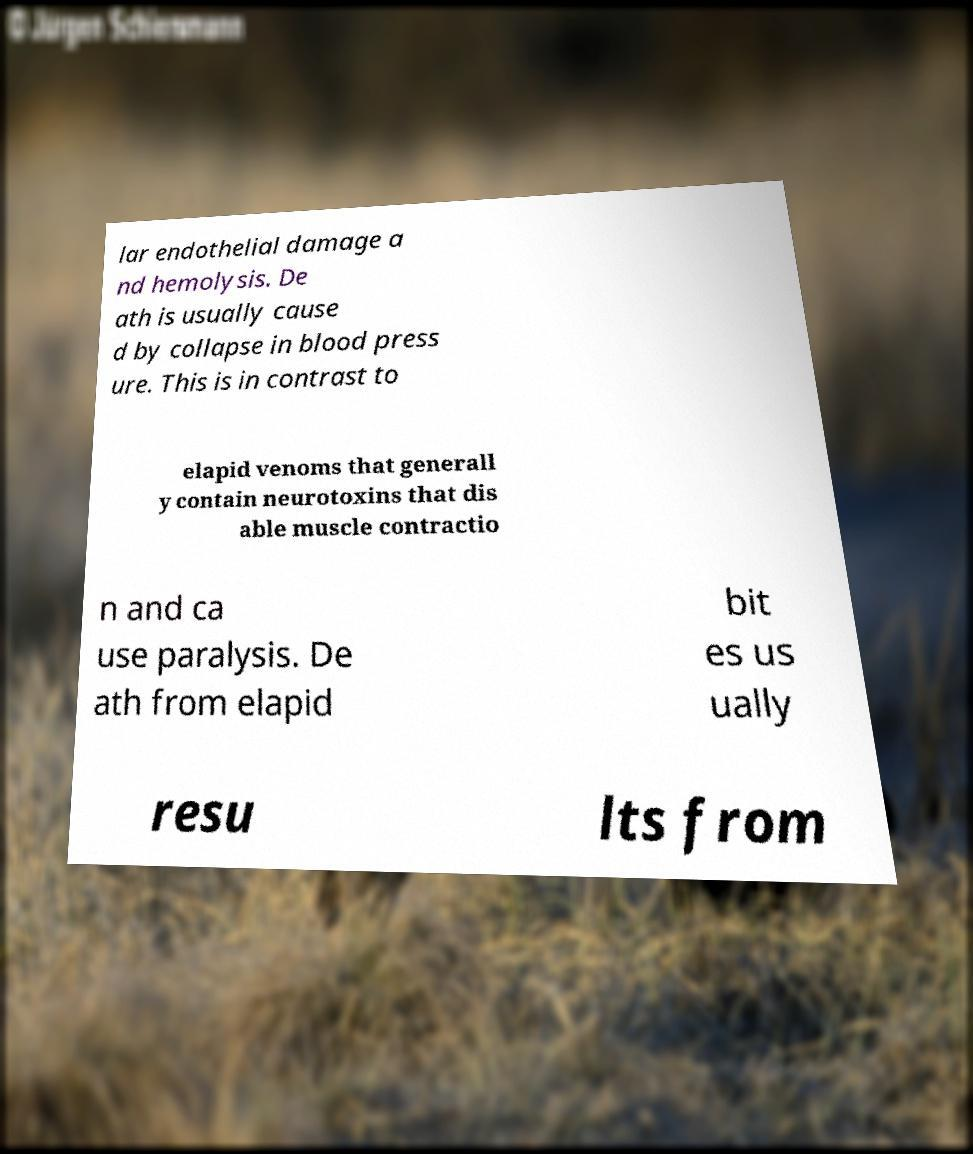There's text embedded in this image that I need extracted. Can you transcribe it verbatim? lar endothelial damage a nd hemolysis. De ath is usually cause d by collapse in blood press ure. This is in contrast to elapid venoms that generall y contain neurotoxins that dis able muscle contractio n and ca use paralysis. De ath from elapid bit es us ually resu lts from 